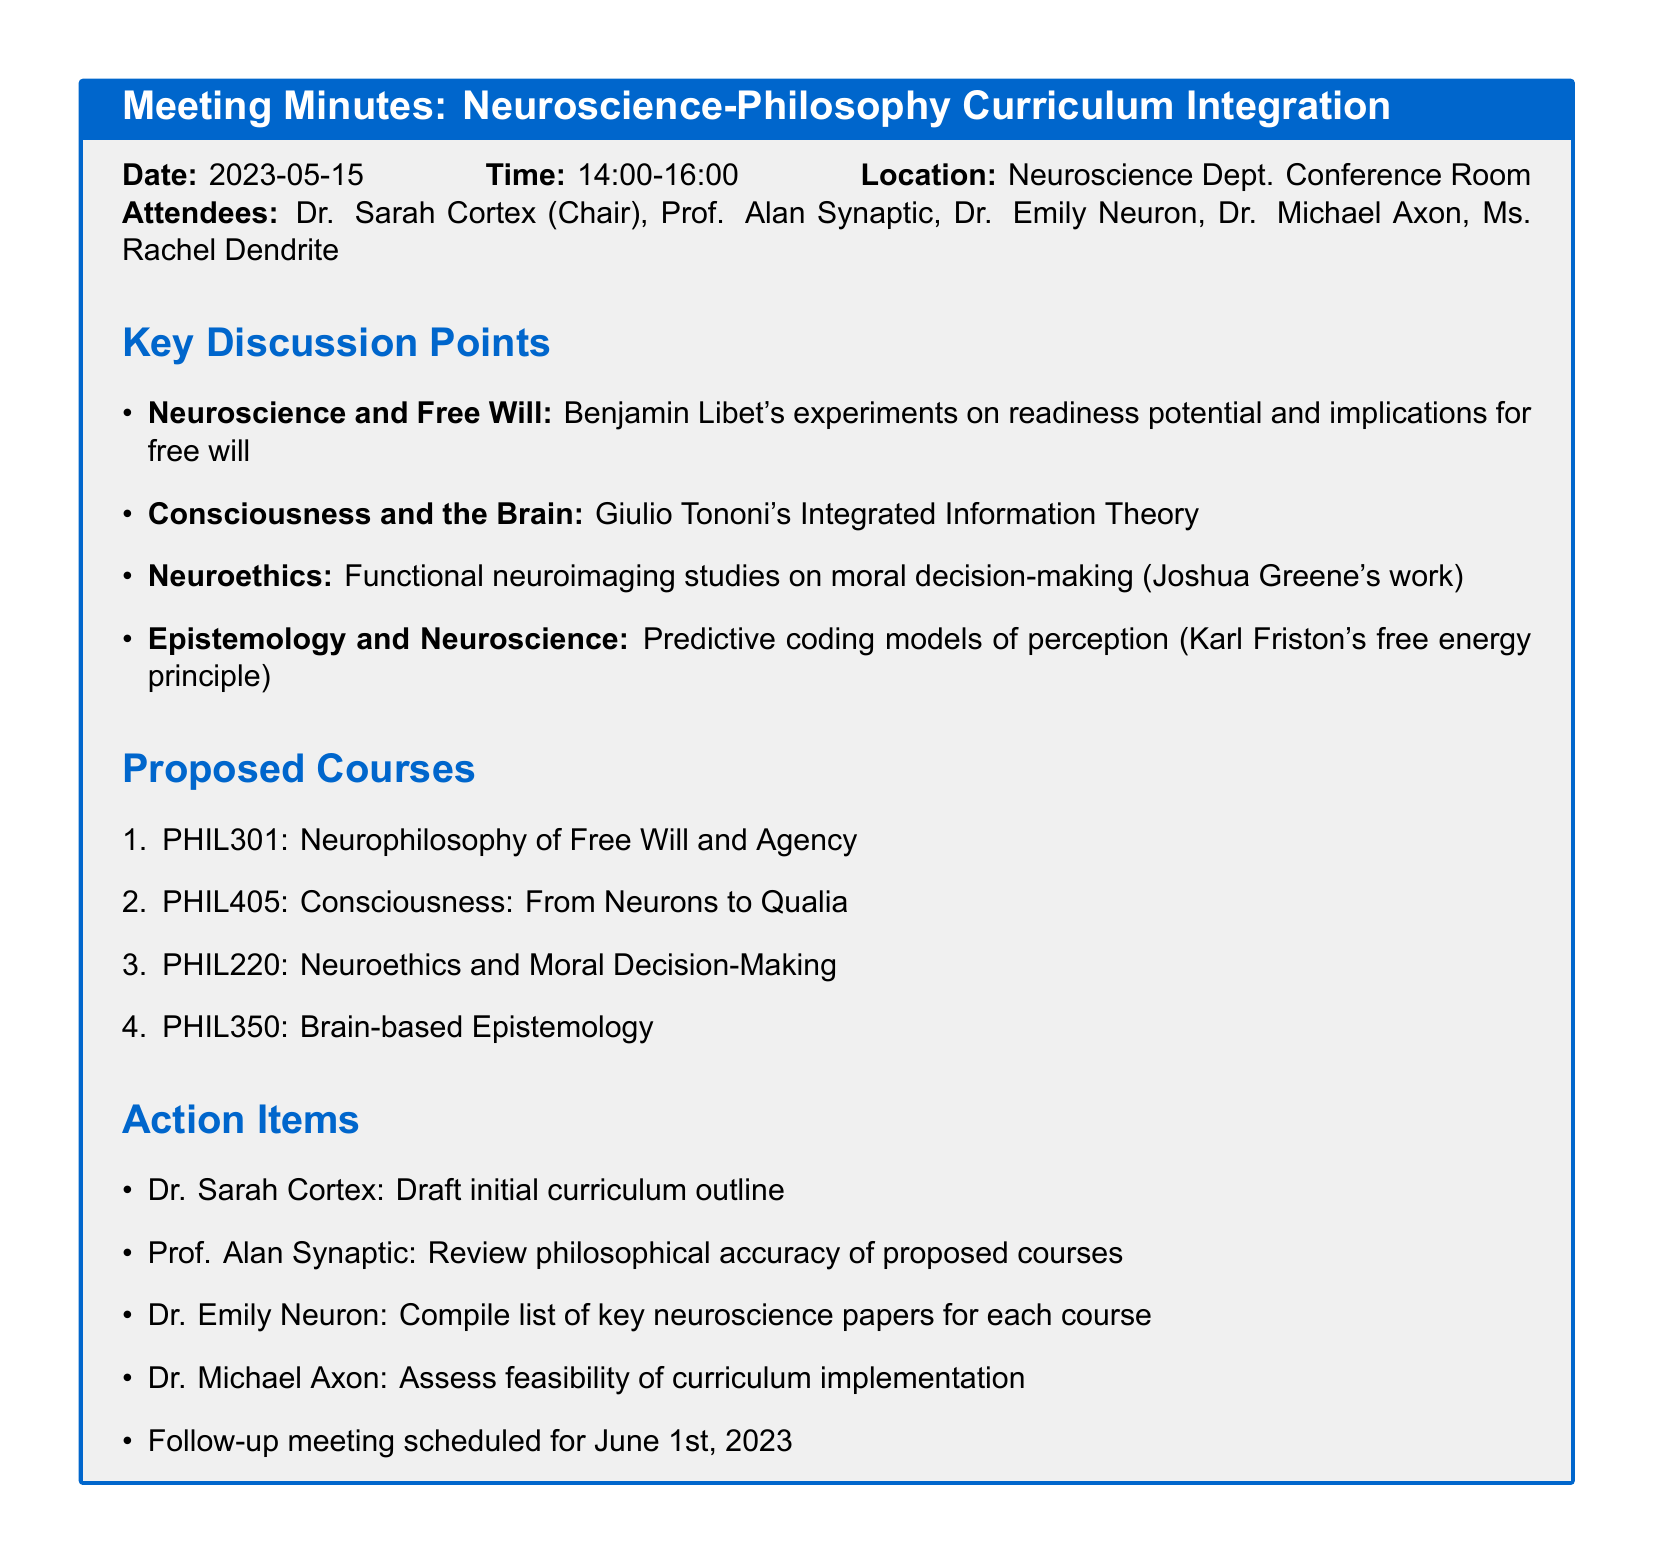What is the date of the meeting? The date of the meeting is specified in the meeting details section.
Answer: 2023-05-15 Who chaired the meeting? The chair of the meeting is mentioned in the attendees list.
Answer: Dr. Sarah Cortex What is the proposed course that focuses on consciousness? The proposed courses section lists courses by their titles.
Answer: PHIL405: Consciousness: From Neurons to Qualia What experimental findings were discussed regarding free will? The key discussion points include specific findings related to free will in neuroscience.
Answer: Benjamin Libet's experiments When is the follow-up meeting scheduled? The follow-up meeting date is mentioned under action items.
Answer: June 1st, 2023 Who is responsible for reviewing the philosophical accuracy of proposed courses? The action items list assigns specific responsibilities to attendees.
Answer: Prof. Alan Synaptic What neuroscience theory was explored in relation to consciousness? Key discussion points mention theories relevant to philosophical inquiries.
Answer: Giulio Tononi's Integrated Information Theory Which course covers neuroethics? The proposed courses section lists courses relevant to neuroethics.
Answer: PHIL220: Neuroethics and Moral Decision-Making 